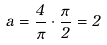Convert formula to latex. <formula><loc_0><loc_0><loc_500><loc_500>a = \frac { 4 } { \pi } \cdot \frac { \pi } { 2 } = 2</formula> 